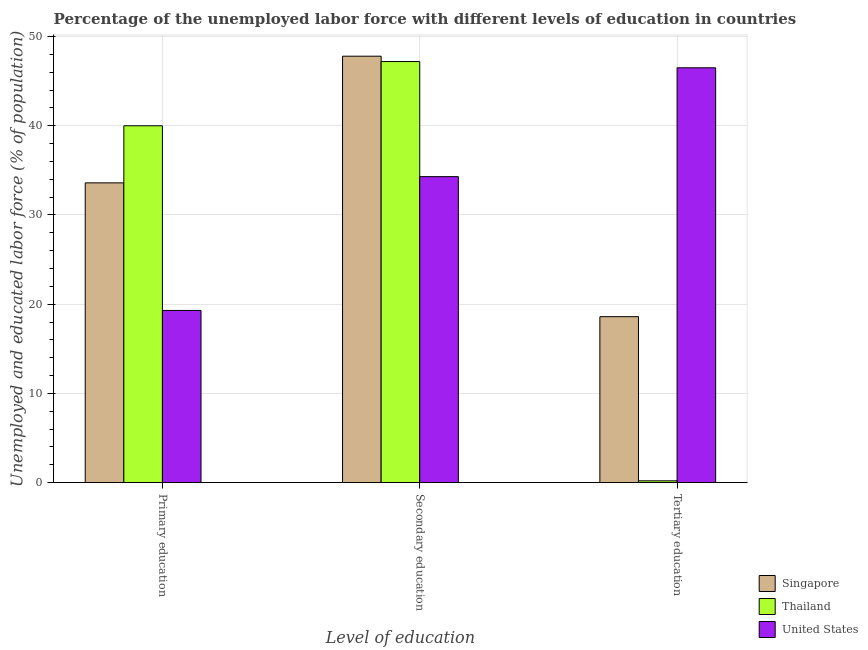How many different coloured bars are there?
Your answer should be compact. 3. How many groups of bars are there?
Ensure brevity in your answer.  3. What is the label of the 2nd group of bars from the left?
Give a very brief answer. Secondary education. What is the percentage of labor force who received secondary education in United States?
Ensure brevity in your answer.  34.3. Across all countries, what is the maximum percentage of labor force who received secondary education?
Make the answer very short. 47.8. Across all countries, what is the minimum percentage of labor force who received primary education?
Provide a short and direct response. 19.3. In which country was the percentage of labor force who received primary education minimum?
Your answer should be compact. United States. What is the total percentage of labor force who received primary education in the graph?
Offer a very short reply. 92.9. What is the difference between the percentage of labor force who received tertiary education in Singapore and that in Thailand?
Ensure brevity in your answer.  18.4. What is the difference between the percentage of labor force who received tertiary education in United States and the percentage of labor force who received secondary education in Thailand?
Ensure brevity in your answer.  -0.7. What is the average percentage of labor force who received primary education per country?
Your answer should be very brief. 30.97. What is the difference between the percentage of labor force who received primary education and percentage of labor force who received tertiary education in United States?
Your answer should be very brief. -27.2. What is the ratio of the percentage of labor force who received secondary education in Thailand to that in Singapore?
Keep it short and to the point. 0.99. What is the difference between the highest and the second highest percentage of labor force who received tertiary education?
Give a very brief answer. 27.9. What is the difference between the highest and the lowest percentage of labor force who received secondary education?
Your answer should be very brief. 13.5. In how many countries, is the percentage of labor force who received primary education greater than the average percentage of labor force who received primary education taken over all countries?
Make the answer very short. 2. Is the sum of the percentage of labor force who received primary education in Thailand and Singapore greater than the maximum percentage of labor force who received secondary education across all countries?
Provide a short and direct response. Yes. What does the 3rd bar from the left in Secondary education represents?
Offer a terse response. United States. What does the 1st bar from the right in Tertiary education represents?
Your response must be concise. United States. Is it the case that in every country, the sum of the percentage of labor force who received primary education and percentage of labor force who received secondary education is greater than the percentage of labor force who received tertiary education?
Your response must be concise. Yes. How many countries are there in the graph?
Make the answer very short. 3. What is the difference between two consecutive major ticks on the Y-axis?
Your answer should be very brief. 10. Does the graph contain any zero values?
Offer a very short reply. No. Does the graph contain grids?
Make the answer very short. Yes. Where does the legend appear in the graph?
Your answer should be very brief. Bottom right. How many legend labels are there?
Your answer should be very brief. 3. How are the legend labels stacked?
Make the answer very short. Vertical. What is the title of the graph?
Make the answer very short. Percentage of the unemployed labor force with different levels of education in countries. Does "Congo (Republic)" appear as one of the legend labels in the graph?
Offer a very short reply. No. What is the label or title of the X-axis?
Keep it short and to the point. Level of education. What is the label or title of the Y-axis?
Offer a terse response. Unemployed and educated labor force (% of population). What is the Unemployed and educated labor force (% of population) of Singapore in Primary education?
Make the answer very short. 33.6. What is the Unemployed and educated labor force (% of population) in United States in Primary education?
Give a very brief answer. 19.3. What is the Unemployed and educated labor force (% of population) of Singapore in Secondary education?
Offer a terse response. 47.8. What is the Unemployed and educated labor force (% of population) in Thailand in Secondary education?
Keep it short and to the point. 47.2. What is the Unemployed and educated labor force (% of population) of United States in Secondary education?
Ensure brevity in your answer.  34.3. What is the Unemployed and educated labor force (% of population) in Singapore in Tertiary education?
Offer a terse response. 18.6. What is the Unemployed and educated labor force (% of population) of Thailand in Tertiary education?
Ensure brevity in your answer.  0.2. What is the Unemployed and educated labor force (% of population) of United States in Tertiary education?
Your answer should be compact. 46.5. Across all Level of education, what is the maximum Unemployed and educated labor force (% of population) of Singapore?
Provide a succinct answer. 47.8. Across all Level of education, what is the maximum Unemployed and educated labor force (% of population) of Thailand?
Ensure brevity in your answer.  47.2. Across all Level of education, what is the maximum Unemployed and educated labor force (% of population) of United States?
Your response must be concise. 46.5. Across all Level of education, what is the minimum Unemployed and educated labor force (% of population) in Singapore?
Provide a short and direct response. 18.6. Across all Level of education, what is the minimum Unemployed and educated labor force (% of population) of Thailand?
Your answer should be compact. 0.2. Across all Level of education, what is the minimum Unemployed and educated labor force (% of population) in United States?
Your answer should be very brief. 19.3. What is the total Unemployed and educated labor force (% of population) in Singapore in the graph?
Offer a very short reply. 100. What is the total Unemployed and educated labor force (% of population) in Thailand in the graph?
Provide a short and direct response. 87.4. What is the total Unemployed and educated labor force (% of population) in United States in the graph?
Offer a very short reply. 100.1. What is the difference between the Unemployed and educated labor force (% of population) of United States in Primary education and that in Secondary education?
Your answer should be very brief. -15. What is the difference between the Unemployed and educated labor force (% of population) of Thailand in Primary education and that in Tertiary education?
Provide a short and direct response. 39.8. What is the difference between the Unemployed and educated labor force (% of population) of United States in Primary education and that in Tertiary education?
Give a very brief answer. -27.2. What is the difference between the Unemployed and educated labor force (% of population) of Singapore in Secondary education and that in Tertiary education?
Offer a terse response. 29.2. What is the difference between the Unemployed and educated labor force (% of population) in Thailand in Secondary education and that in Tertiary education?
Provide a short and direct response. 47. What is the difference between the Unemployed and educated labor force (% of population) in Thailand in Primary education and the Unemployed and educated labor force (% of population) in United States in Secondary education?
Your answer should be compact. 5.7. What is the difference between the Unemployed and educated labor force (% of population) of Singapore in Primary education and the Unemployed and educated labor force (% of population) of Thailand in Tertiary education?
Offer a terse response. 33.4. What is the difference between the Unemployed and educated labor force (% of population) in Thailand in Primary education and the Unemployed and educated labor force (% of population) in United States in Tertiary education?
Provide a succinct answer. -6.5. What is the difference between the Unemployed and educated labor force (% of population) in Singapore in Secondary education and the Unemployed and educated labor force (% of population) in Thailand in Tertiary education?
Make the answer very short. 47.6. What is the difference between the Unemployed and educated labor force (% of population) of Thailand in Secondary education and the Unemployed and educated labor force (% of population) of United States in Tertiary education?
Give a very brief answer. 0.7. What is the average Unemployed and educated labor force (% of population) in Singapore per Level of education?
Give a very brief answer. 33.33. What is the average Unemployed and educated labor force (% of population) in Thailand per Level of education?
Provide a succinct answer. 29.13. What is the average Unemployed and educated labor force (% of population) in United States per Level of education?
Offer a very short reply. 33.37. What is the difference between the Unemployed and educated labor force (% of population) in Singapore and Unemployed and educated labor force (% of population) in Thailand in Primary education?
Give a very brief answer. -6.4. What is the difference between the Unemployed and educated labor force (% of population) of Thailand and Unemployed and educated labor force (% of population) of United States in Primary education?
Your answer should be compact. 20.7. What is the difference between the Unemployed and educated labor force (% of population) in Singapore and Unemployed and educated labor force (% of population) in United States in Tertiary education?
Provide a succinct answer. -27.9. What is the difference between the Unemployed and educated labor force (% of population) in Thailand and Unemployed and educated labor force (% of population) in United States in Tertiary education?
Ensure brevity in your answer.  -46.3. What is the ratio of the Unemployed and educated labor force (% of population) of Singapore in Primary education to that in Secondary education?
Give a very brief answer. 0.7. What is the ratio of the Unemployed and educated labor force (% of population) of Thailand in Primary education to that in Secondary education?
Your answer should be very brief. 0.85. What is the ratio of the Unemployed and educated labor force (% of population) in United States in Primary education to that in Secondary education?
Ensure brevity in your answer.  0.56. What is the ratio of the Unemployed and educated labor force (% of population) in Singapore in Primary education to that in Tertiary education?
Ensure brevity in your answer.  1.81. What is the ratio of the Unemployed and educated labor force (% of population) of Thailand in Primary education to that in Tertiary education?
Ensure brevity in your answer.  200. What is the ratio of the Unemployed and educated labor force (% of population) of United States in Primary education to that in Tertiary education?
Your response must be concise. 0.42. What is the ratio of the Unemployed and educated labor force (% of population) in Singapore in Secondary education to that in Tertiary education?
Provide a short and direct response. 2.57. What is the ratio of the Unemployed and educated labor force (% of population) in Thailand in Secondary education to that in Tertiary education?
Your answer should be compact. 236. What is the ratio of the Unemployed and educated labor force (% of population) of United States in Secondary education to that in Tertiary education?
Offer a very short reply. 0.74. What is the difference between the highest and the second highest Unemployed and educated labor force (% of population) in Thailand?
Your response must be concise. 7.2. What is the difference between the highest and the second highest Unemployed and educated labor force (% of population) in United States?
Make the answer very short. 12.2. What is the difference between the highest and the lowest Unemployed and educated labor force (% of population) in Singapore?
Provide a short and direct response. 29.2. What is the difference between the highest and the lowest Unemployed and educated labor force (% of population) in Thailand?
Give a very brief answer. 47. What is the difference between the highest and the lowest Unemployed and educated labor force (% of population) in United States?
Provide a short and direct response. 27.2. 